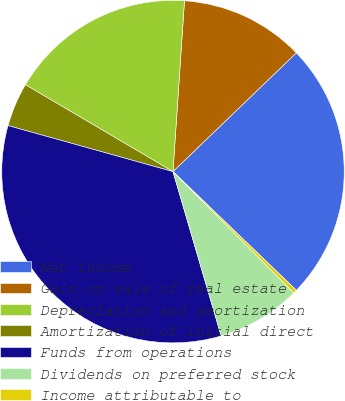Convert chart. <chart><loc_0><loc_0><loc_500><loc_500><pie_chart><fcel>Net income<fcel>Gain on sale of real estate<fcel>Depreciation and amortization<fcel>Amortization of initial direct<fcel>Funds from operations<fcel>Dividends on preferred stock<fcel>Income attributable to<nl><fcel>24.39%<fcel>11.73%<fcel>17.6%<fcel>4.14%<fcel>33.87%<fcel>7.93%<fcel>0.34%<nl></chart> 